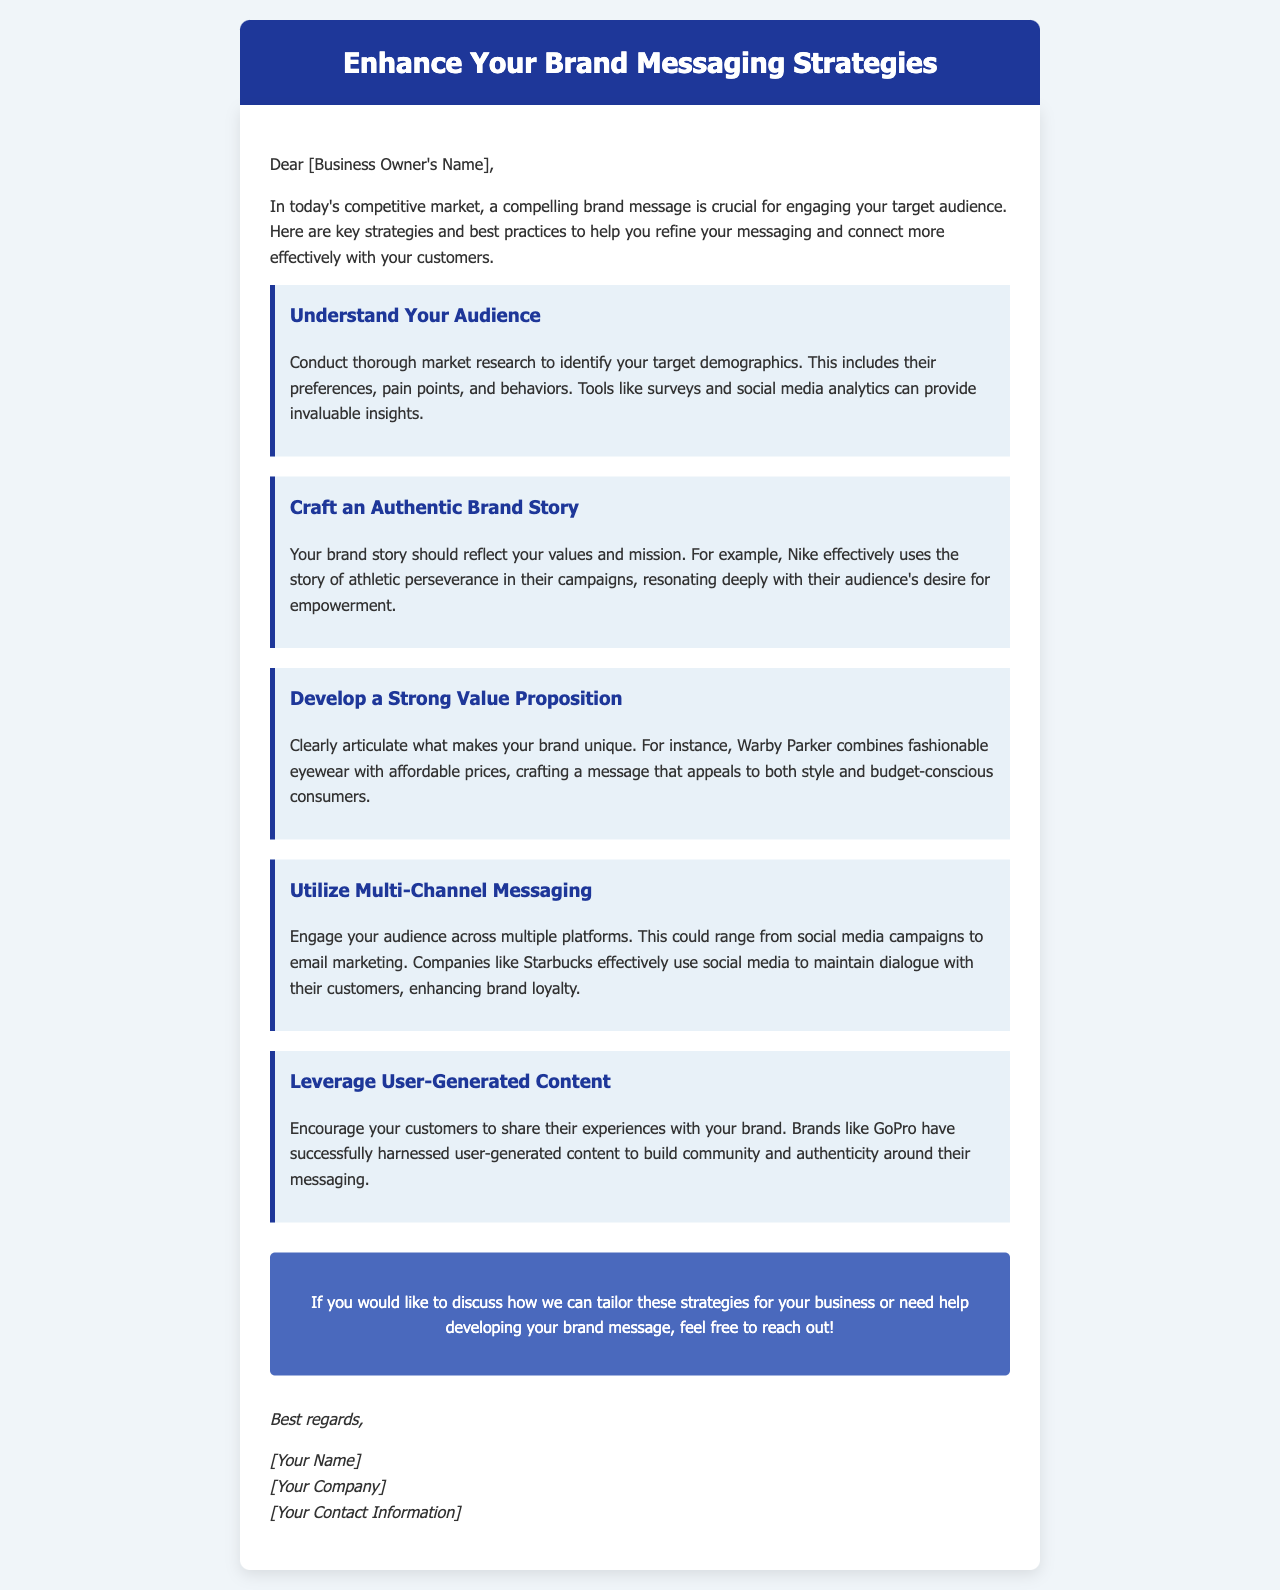What is the title of the email? The title is prominently displayed at the top of the document within the header section.
Answer: Enhance Your Brand Messaging Strategies What is the first strategy mentioned? This information is found within the content of the email, specifically in the strategy sections.
Answer: Understand Your Audience Which brand is used as an example for an authentic brand story? The example is provided within the context of the second strategy, illustrating how to tell a brand story.
Answer: Nike What should be clearly articulated as part of the brand messaging? The emphasis on articulation is specified in the section discussing value propositions.
Answer: Unique value proposition Which company is mentioned regarding multi-channel messaging? This reference is included in the strategy section discussing the benefits of engaging through various platforms.
Answer: Starbucks What type of content is encouraged to leverage in brand messaging? The relevant strategy discusses enhancing brand messaging through sharing of customer experiences.
Answer: User-generated content How many strategies are listed in the email? This information can be calculated by counting the individual strategy sections in the content.
Answer: Five What is the call to action at the end of the email? This is indicated in the CTA section, prompting action after discussing strategies.
Answer: Discuss strategies or help with brand message 